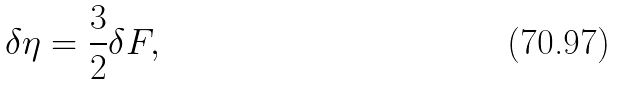Convert formula to latex. <formula><loc_0><loc_0><loc_500><loc_500>\delta \eta = \frac { 3 } { 2 } \delta F ,</formula> 